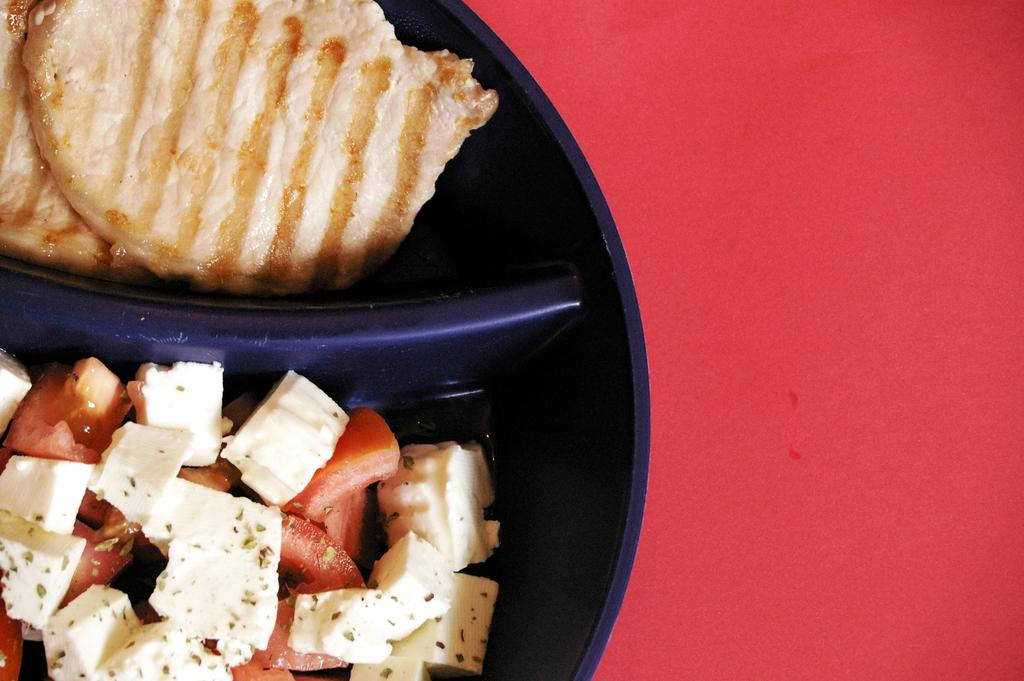What is in the bowl that is visible in the image? There is food in a bowl in the image. How many thumbs can be seen interacting with the food in the image? There is no thumb visible in the image, as it is focused on the bowl of food. What type of dinosaurs can be seen in the image? There are no dinosaurs present in the image; it features a bowl of food. 